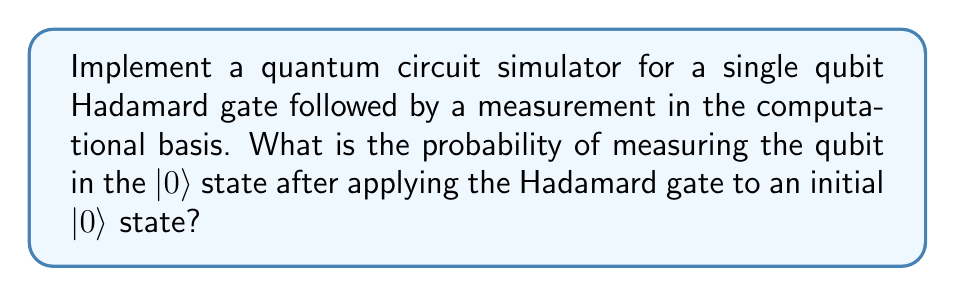Solve this math problem. Let's break this down step-by-step:

1) First, we need to represent the initial state $|0\rangle$ as a column vector:

   $$|0\rangle = \begin{pmatrix} 1 \\ 0 \end{pmatrix}$$

2) The Hadamard gate is represented by the matrix:

   $$H = \frac{1}{\sqrt{2}} \begin{pmatrix} 1 & 1 \\ 1 & -1 \end{pmatrix}$$

3) To apply the Hadamard gate to the initial state, we multiply the H matrix by the state vector:

   $$H|0\rangle = \frac{1}{\sqrt{2}} \begin{pmatrix} 1 & 1 \\ 1 & -1 \end{pmatrix} \begin{pmatrix} 1 \\ 0 \end{pmatrix} = \frac{1}{\sqrt{2}} \begin{pmatrix} 1 \\ 1 \end{pmatrix}$$

4) The resulting state is:

   $$|\psi\rangle = \frac{1}{\sqrt{2}}(|0\rangle + |1\rangle)$$

5) To find the probability of measuring $|0\rangle$, we calculate the square of the absolute value of the amplitude of $|0\rangle$ in this superposition:

   $$P(|0\rangle) = \left|\frac{1}{\sqrt{2}}\right|^2 = \frac{1}{2}$$

Thus, the probability of measuring the qubit in the $|0\rangle$ state after applying the Hadamard gate is 1/2 or 50%.
Answer: $\frac{1}{2}$ 